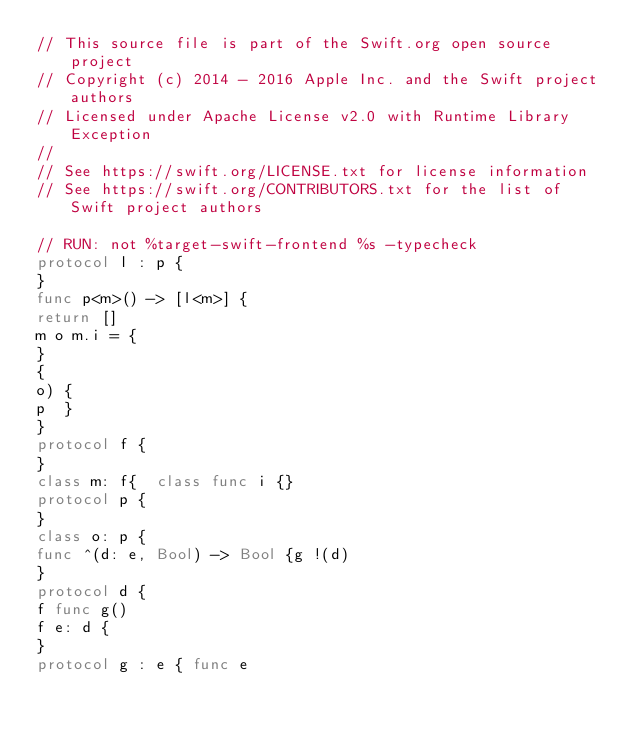Convert code to text. <code><loc_0><loc_0><loc_500><loc_500><_Swift_>// This source file is part of the Swift.org open source project
// Copyright (c) 2014 - 2016 Apple Inc. and the Swift project authors
// Licensed under Apache License v2.0 with Runtime Library Exception
//
// See https://swift.org/LICENSE.txt for license information
// See https://swift.org/CONTRIBUTORS.txt for the list of Swift project authors

// RUN: not %target-swift-frontend %s -typecheck
protocol l : p {
}
func p<m>() -> [l<m>] {
return []
m o m.i = {
}
{
o) {
p  }
}
protocol f {
}
class m: f{  class func i {}
protocol p {
}
class o: p {
func ^(d: e, Bool) -> Bool {g !(d)
}
protocol d {
f func g()
f e: d {
}
protocol g : e { func e
</code> 